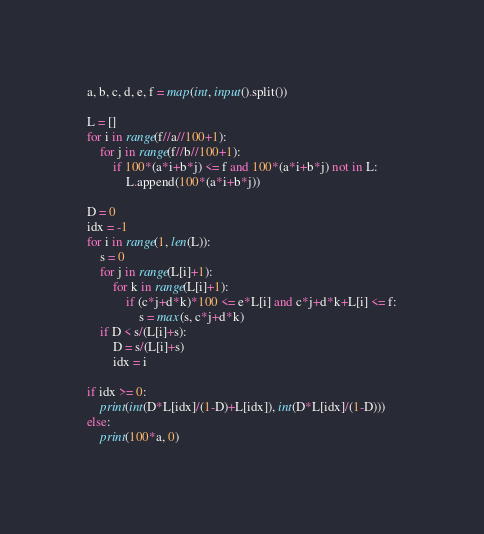<code> <loc_0><loc_0><loc_500><loc_500><_Python_>a, b, c, d, e, f = map(int, input().split())

L = []
for i in range(f//a//100+1):
    for j in range(f//b//100+1):
        if 100*(a*i+b*j) <= f and 100*(a*i+b*j) not in L:
            L.append(100*(a*i+b*j))
            
D = 0
idx = -1
for i in range(1, len(L)):
    s = 0
    for j in range(L[i]+1):
        for k in range(L[i]+1):
            if (c*j+d*k)*100 <= e*L[i] and c*j+d*k+L[i] <= f:
                s = max(s, c*j+d*k)
    if D < s/(L[i]+s):
        D = s/(L[i]+s)
        idx = i
    
if idx >= 0:
    print(int(D*L[idx]/(1-D)+L[idx]), int(D*L[idx]/(1-D)))
else:
    print(100*a, 0)</code> 